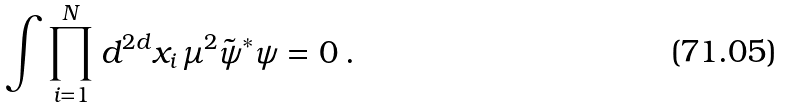<formula> <loc_0><loc_0><loc_500><loc_500>\int \prod _ { i = 1 } ^ { N } d ^ { 2 d } x _ { i } \, \mu ^ { 2 } \tilde { \psi } ^ { * } \psi = 0 \, .</formula> 